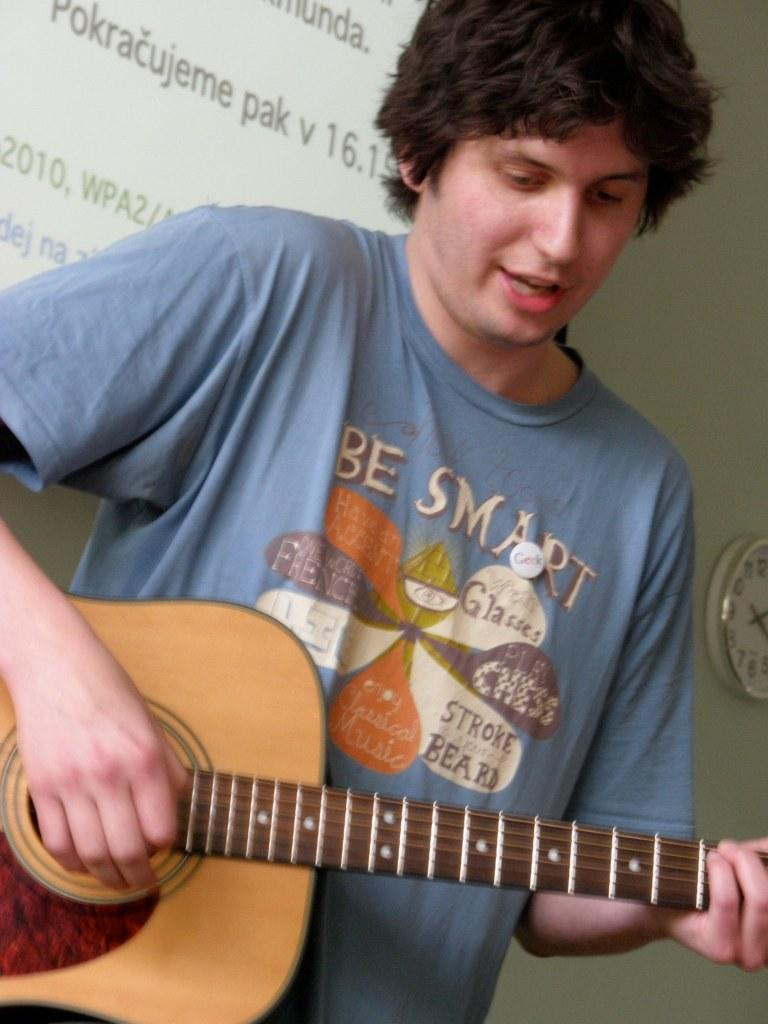What is the man in the image doing? The man is playing a guitar in the image. What can be seen in the background of the image? There is a clock and a screen in the background of the image. What type of action is the police taking in the image? There is no police presence or action in the image; it features a man playing a guitar with a clock and a screen in the background. Can you tell me what the man is writing in his notebook during the performance? There is no notebook present in the image, and the man is not writing anything; he is playing a guitar. 